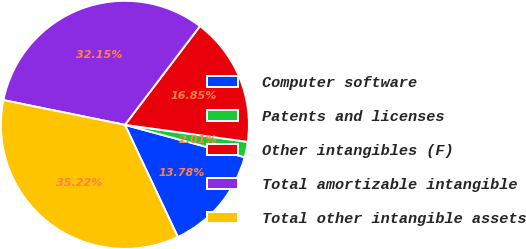Convert chart. <chart><loc_0><loc_0><loc_500><loc_500><pie_chart><fcel>Computer software<fcel>Patents and licenses<fcel>Other intangibles (F)<fcel>Total amortizable intangible<fcel>Total other intangible assets<nl><fcel>13.78%<fcel>2.01%<fcel>16.85%<fcel>32.15%<fcel>35.22%<nl></chart> 